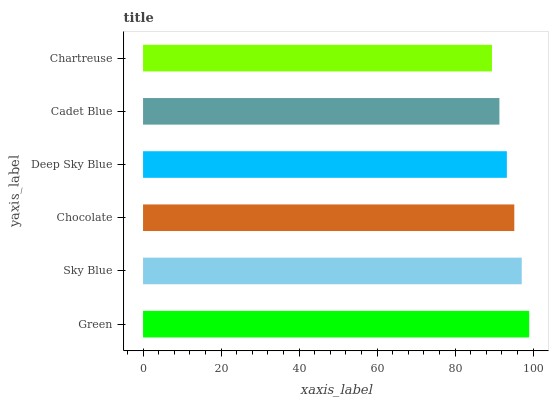Is Chartreuse the minimum?
Answer yes or no. Yes. Is Green the maximum?
Answer yes or no. Yes. Is Sky Blue the minimum?
Answer yes or no. No. Is Sky Blue the maximum?
Answer yes or no. No. Is Green greater than Sky Blue?
Answer yes or no. Yes. Is Sky Blue less than Green?
Answer yes or no. Yes. Is Sky Blue greater than Green?
Answer yes or no. No. Is Green less than Sky Blue?
Answer yes or no. No. Is Chocolate the high median?
Answer yes or no. Yes. Is Deep Sky Blue the low median?
Answer yes or no. Yes. Is Chartreuse the high median?
Answer yes or no. No. Is Cadet Blue the low median?
Answer yes or no. No. 